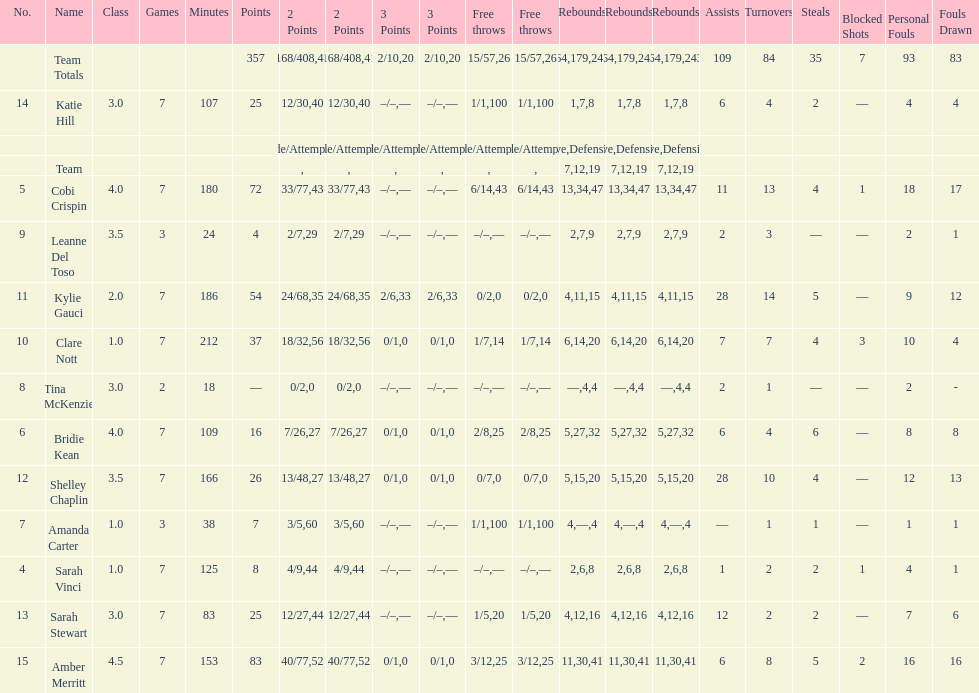What is the difference between the highest scoring player's points and the lowest scoring player's points? 83. 